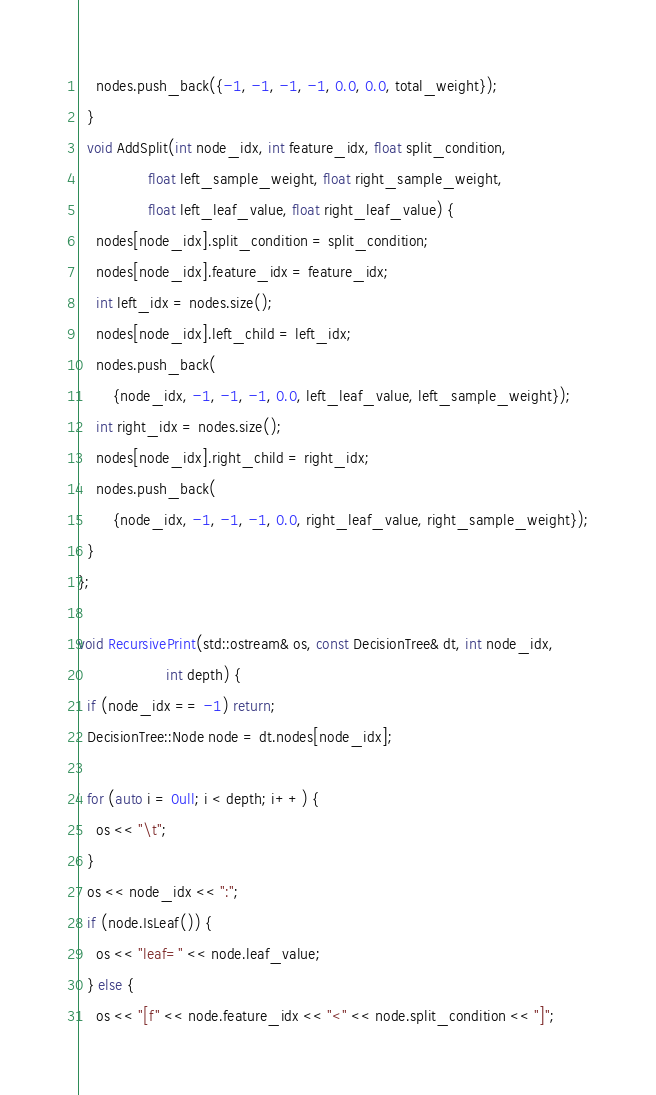Convert code to text. <code><loc_0><loc_0><loc_500><loc_500><_Cuda_>    nodes.push_back({-1, -1, -1, -1, 0.0, 0.0, total_weight});
  }
  void AddSplit(int node_idx, int feature_idx, float split_condition,
                float left_sample_weight, float right_sample_weight,
                float left_leaf_value, float right_leaf_value) {
    nodes[node_idx].split_condition = split_condition;
    nodes[node_idx].feature_idx = feature_idx;
    int left_idx = nodes.size();
    nodes[node_idx].left_child = left_idx;
    nodes.push_back(
        {node_idx, -1, -1, -1, 0.0, left_leaf_value, left_sample_weight});
    int right_idx = nodes.size();
    nodes[node_idx].right_child = right_idx;
    nodes.push_back(
        {node_idx, -1, -1, -1, 0.0, right_leaf_value, right_sample_weight});
  }
};

void RecursivePrint(std::ostream& os, const DecisionTree& dt, int node_idx,
                    int depth) {
  if (node_idx == -1) return;
  DecisionTree::Node node = dt.nodes[node_idx];

  for (auto i = 0ull; i < depth; i++) {
    os << "\t";
  }
  os << node_idx << ":";
  if (node.IsLeaf()) {
    os << "leaf=" << node.leaf_value;
  } else {
    os << "[f" << node.feature_idx << "<" << node.split_condition << "]";</code> 